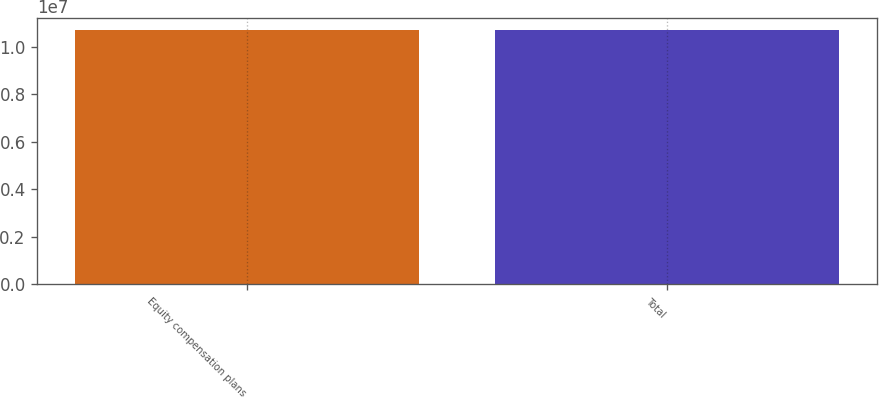Convert chart to OTSL. <chart><loc_0><loc_0><loc_500><loc_500><bar_chart><fcel>Equity compensation plans<fcel>Total<nl><fcel>1.06762e+07<fcel>1.06762e+07<nl></chart> 